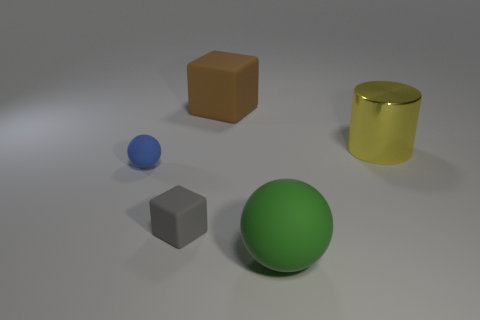Add 4 brown cubes. How many objects exist? 9 Subtract all blue balls. How many balls are left? 1 Subtract all spheres. How many objects are left? 3 Subtract 1 brown cubes. How many objects are left? 4 Subtract 1 cubes. How many cubes are left? 1 Subtract all blue cylinders. Subtract all purple cubes. How many cylinders are left? 1 Subtract all matte blocks. Subtract all tiny green balls. How many objects are left? 3 Add 5 big brown rubber blocks. How many big brown rubber blocks are left? 6 Add 5 big blue rubber balls. How many big blue rubber balls exist? 5 